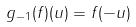Convert formula to latex. <formula><loc_0><loc_0><loc_500><loc_500>g _ { - 1 } ( f ) ( u ) = f ( - u )</formula> 